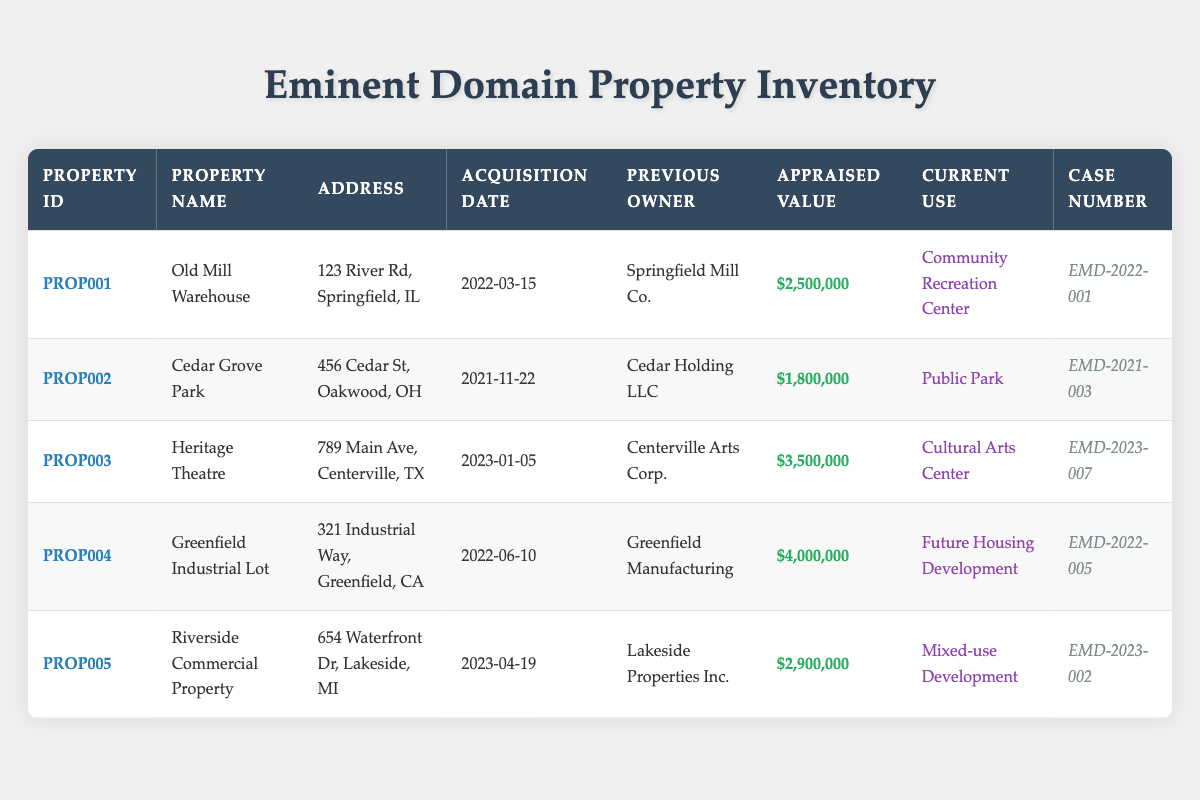What property has the highest appraised value? By reviewing the appraised values in the table, I can determine that the "Greenfield Industrial Lot" has the highest value at $4,000,000.
Answer: Greenfield Industrial Lot Which property was acquired on March 15, 2022? The table lists the acquisition dates along with property names. "Old Mill Warehouse" was acquired on March 15, 2022.
Answer: Old Mill Warehouse Is Riverside Commercial Property currently used for residential purposes? According to the current use listed in the table, "Riverside Commercial Property" is used for "Mixed-use Development," which indicates it is not strictly residential.
Answer: No What is the total appraised value of all properties listed? I need to sum the appraised values: 2,500,000 + 1,800,000 + 3,500,000 + 4,000,000 + 2,900,000 = 14,700,000. Thus, the total appraised value is $14,700,000.
Answer: 14,700,000 Which property had the previous owner Cedar Holding LLC? The table indicates that "Cedar Grove Park" was previously owned by Cedar Holding LLC.
Answer: Cedar Grove Park What is the average appraised value of the properties acquired in 2023? The appraised values for 2023 entries are 3,500,000 and 2,900,000. The average is (3,500,000 + 2,900,000) / 2 = 3,200,000.
Answer: 3,200,000 Are there any properties currently used as parks? The table shows that "Cedar Grove Park" is the only property currently designated as "Public Park."
Answer: Yes How many properties are located in Illinois? Only one property listed in the table, "Old Mill Warehouse," is located in Illinois.
Answer: 1 What is the case number for the property that is a Cultural Arts Center? The table shows that "Heritage Theatre," which is a Cultural Arts Center, has the case number EMD-2023-007.
Answer: EMD-2023-007 